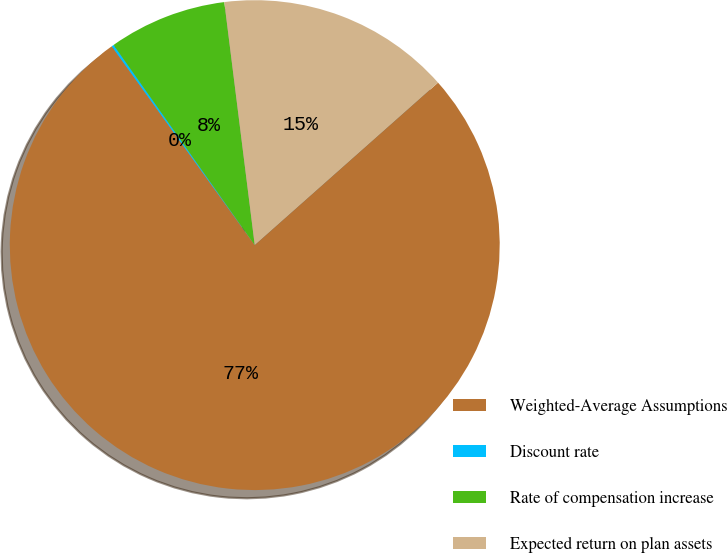Convert chart. <chart><loc_0><loc_0><loc_500><loc_500><pie_chart><fcel>Weighted-Average Assumptions<fcel>Discount rate<fcel>Rate of compensation increase<fcel>Expected return on plan assets<nl><fcel>76.62%<fcel>0.15%<fcel>7.79%<fcel>15.44%<nl></chart> 